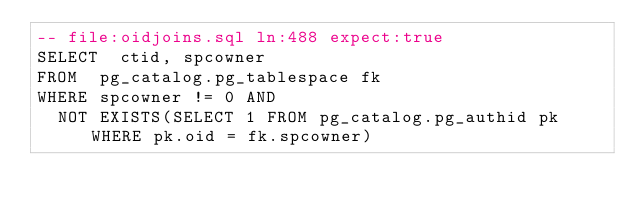<code> <loc_0><loc_0><loc_500><loc_500><_SQL_>-- file:oidjoins.sql ln:488 expect:true
SELECT	ctid, spcowner
FROM	pg_catalog.pg_tablespace fk
WHERE	spcowner != 0 AND
	NOT EXISTS(SELECT 1 FROM pg_catalog.pg_authid pk WHERE pk.oid = fk.spcowner)
</code> 